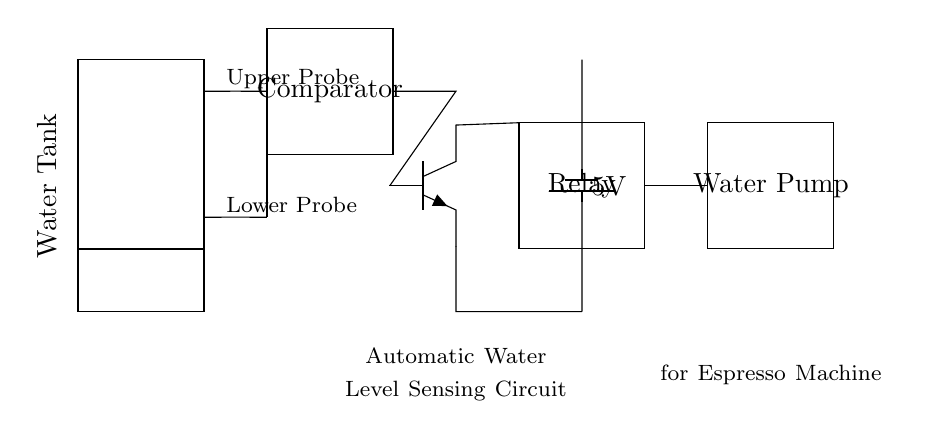What is the main function of the circuit? The circuit is designed to automatically sense the water level in a tank and control the water pump accordingly. The water level is monitored by the probes, and when a certain level is reached, the comparator activates the transistor, which in turn operates the relay and pump.
Answer: Automatically sense water level How many probes are used in this circuit? There are two probes in the circuit: an upper probe and a lower probe. These probes detect the water level by measuring the electrical conductivity between them when submerged.
Answer: Two probes What type of transistor is depicted in the circuit? The circuit shows an NPN transistor, which is used to switch the relay on or off based on the signals from the comparator depending on the water level sensed.
Answer: NPN What is the supply voltage for this circuit? The circuit operates on a power supply voltage of 5 volts, as indicated by the battery symbol in the diagram.
Answer: 5 volts What component activates the water pump in this circuit? The relay is the component that activates the water pump. When the transistor is turned on by the comparator, it triggers the relay, which allows current to pass to the water pump, enabling it to operate.
Answer: Relay How do the upper and lower probes interact in this circuit? The upper and lower probes interact with the comparator to determine if the water level is too high or too low. If the water level is below the lower probe, the comparator activates the transistor, which in turn switches on the relay to enable the water pump. If the level is above the upper probe, the transistor may deactivate the relay to prevent overflow.
Answer: They control the water level detection 